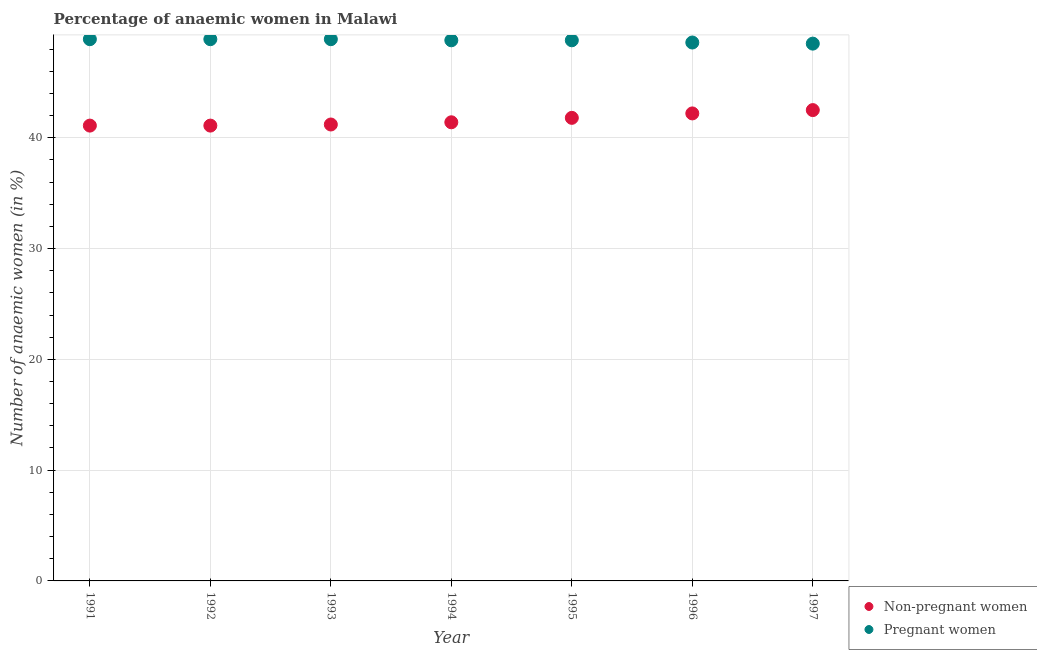Is the number of dotlines equal to the number of legend labels?
Keep it short and to the point. Yes. What is the percentage of non-pregnant anaemic women in 1997?
Your answer should be compact. 42.5. Across all years, what is the maximum percentage of pregnant anaemic women?
Provide a succinct answer. 48.9. Across all years, what is the minimum percentage of non-pregnant anaemic women?
Offer a very short reply. 41.1. What is the total percentage of pregnant anaemic women in the graph?
Offer a very short reply. 341.4. What is the difference between the percentage of non-pregnant anaemic women in 1991 and that in 1996?
Your answer should be very brief. -1.1. What is the difference between the percentage of non-pregnant anaemic women in 1997 and the percentage of pregnant anaemic women in 1992?
Provide a short and direct response. -6.4. What is the average percentage of pregnant anaemic women per year?
Make the answer very short. 48.77. In the year 1997, what is the difference between the percentage of non-pregnant anaemic women and percentage of pregnant anaemic women?
Keep it short and to the point. -6. What is the ratio of the percentage of pregnant anaemic women in 1991 to that in 1997?
Ensure brevity in your answer.  1.01. Is the percentage of non-pregnant anaemic women in 1992 less than that in 1994?
Offer a terse response. Yes. What is the difference between the highest and the lowest percentage of pregnant anaemic women?
Offer a terse response. 0.4. In how many years, is the percentage of pregnant anaemic women greater than the average percentage of pregnant anaemic women taken over all years?
Give a very brief answer. 5. Is the sum of the percentage of non-pregnant anaemic women in 1993 and 1995 greater than the maximum percentage of pregnant anaemic women across all years?
Your response must be concise. Yes. Is the percentage of non-pregnant anaemic women strictly greater than the percentage of pregnant anaemic women over the years?
Provide a succinct answer. No. How many years are there in the graph?
Provide a succinct answer. 7. What is the difference between two consecutive major ticks on the Y-axis?
Offer a very short reply. 10. How are the legend labels stacked?
Make the answer very short. Vertical. What is the title of the graph?
Ensure brevity in your answer.  Percentage of anaemic women in Malawi. Does "Crop" appear as one of the legend labels in the graph?
Give a very brief answer. No. What is the label or title of the X-axis?
Provide a short and direct response. Year. What is the label or title of the Y-axis?
Your response must be concise. Number of anaemic women (in %). What is the Number of anaemic women (in %) of Non-pregnant women in 1991?
Keep it short and to the point. 41.1. What is the Number of anaemic women (in %) of Pregnant women in 1991?
Your response must be concise. 48.9. What is the Number of anaemic women (in %) in Non-pregnant women in 1992?
Your response must be concise. 41.1. What is the Number of anaemic women (in %) of Pregnant women in 1992?
Keep it short and to the point. 48.9. What is the Number of anaemic women (in %) in Non-pregnant women in 1993?
Your answer should be very brief. 41.2. What is the Number of anaemic women (in %) of Pregnant women in 1993?
Your answer should be very brief. 48.9. What is the Number of anaemic women (in %) of Non-pregnant women in 1994?
Provide a succinct answer. 41.4. What is the Number of anaemic women (in %) of Pregnant women in 1994?
Provide a succinct answer. 48.8. What is the Number of anaemic women (in %) in Non-pregnant women in 1995?
Give a very brief answer. 41.8. What is the Number of anaemic women (in %) of Pregnant women in 1995?
Keep it short and to the point. 48.8. What is the Number of anaemic women (in %) of Non-pregnant women in 1996?
Provide a succinct answer. 42.2. What is the Number of anaemic women (in %) of Pregnant women in 1996?
Provide a short and direct response. 48.6. What is the Number of anaemic women (in %) of Non-pregnant women in 1997?
Provide a succinct answer. 42.5. What is the Number of anaemic women (in %) of Pregnant women in 1997?
Your response must be concise. 48.5. Across all years, what is the maximum Number of anaemic women (in %) in Non-pregnant women?
Your response must be concise. 42.5. Across all years, what is the maximum Number of anaemic women (in %) of Pregnant women?
Provide a succinct answer. 48.9. Across all years, what is the minimum Number of anaemic women (in %) of Non-pregnant women?
Make the answer very short. 41.1. Across all years, what is the minimum Number of anaemic women (in %) in Pregnant women?
Offer a very short reply. 48.5. What is the total Number of anaemic women (in %) of Non-pregnant women in the graph?
Your response must be concise. 291.3. What is the total Number of anaemic women (in %) of Pregnant women in the graph?
Your response must be concise. 341.4. What is the difference between the Number of anaemic women (in %) in Non-pregnant women in 1991 and that in 1992?
Your answer should be very brief. 0. What is the difference between the Number of anaemic women (in %) of Pregnant women in 1991 and that in 1992?
Offer a very short reply. 0. What is the difference between the Number of anaemic women (in %) of Pregnant women in 1991 and that in 1993?
Provide a short and direct response. 0. What is the difference between the Number of anaemic women (in %) in Non-pregnant women in 1991 and that in 1995?
Ensure brevity in your answer.  -0.7. What is the difference between the Number of anaemic women (in %) of Non-pregnant women in 1991 and that in 1996?
Your response must be concise. -1.1. What is the difference between the Number of anaemic women (in %) in Pregnant women in 1991 and that in 1996?
Ensure brevity in your answer.  0.3. What is the difference between the Number of anaemic women (in %) of Non-pregnant women in 1992 and that in 1995?
Your response must be concise. -0.7. What is the difference between the Number of anaemic women (in %) in Pregnant women in 1992 and that in 1995?
Make the answer very short. 0.1. What is the difference between the Number of anaemic women (in %) of Non-pregnant women in 1992 and that in 1996?
Give a very brief answer. -1.1. What is the difference between the Number of anaemic women (in %) in Non-pregnant women in 1992 and that in 1997?
Offer a very short reply. -1.4. What is the difference between the Number of anaemic women (in %) in Non-pregnant women in 1993 and that in 1994?
Offer a terse response. -0.2. What is the difference between the Number of anaemic women (in %) in Pregnant women in 1993 and that in 1994?
Ensure brevity in your answer.  0.1. What is the difference between the Number of anaemic women (in %) of Non-pregnant women in 1993 and that in 1996?
Your response must be concise. -1. What is the difference between the Number of anaemic women (in %) in Non-pregnant women in 1993 and that in 1997?
Your response must be concise. -1.3. What is the difference between the Number of anaemic women (in %) of Non-pregnant women in 1994 and that in 1995?
Your answer should be very brief. -0.4. What is the difference between the Number of anaemic women (in %) of Pregnant women in 1994 and that in 1996?
Offer a terse response. 0.2. What is the difference between the Number of anaemic women (in %) in Non-pregnant women in 1995 and that in 1996?
Offer a terse response. -0.4. What is the difference between the Number of anaemic women (in %) of Pregnant women in 1995 and that in 1996?
Give a very brief answer. 0.2. What is the difference between the Number of anaemic women (in %) in Pregnant women in 1996 and that in 1997?
Offer a terse response. 0.1. What is the difference between the Number of anaemic women (in %) in Non-pregnant women in 1991 and the Number of anaemic women (in %) in Pregnant women in 1992?
Make the answer very short. -7.8. What is the difference between the Number of anaemic women (in %) in Non-pregnant women in 1991 and the Number of anaemic women (in %) in Pregnant women in 1993?
Provide a succinct answer. -7.8. What is the difference between the Number of anaemic women (in %) of Non-pregnant women in 1991 and the Number of anaemic women (in %) of Pregnant women in 1996?
Give a very brief answer. -7.5. What is the difference between the Number of anaemic women (in %) of Non-pregnant women in 1992 and the Number of anaemic women (in %) of Pregnant women in 1993?
Give a very brief answer. -7.8. What is the difference between the Number of anaemic women (in %) of Non-pregnant women in 1992 and the Number of anaemic women (in %) of Pregnant women in 1994?
Ensure brevity in your answer.  -7.7. What is the difference between the Number of anaemic women (in %) in Non-pregnant women in 1993 and the Number of anaemic women (in %) in Pregnant women in 1997?
Your answer should be very brief. -7.3. What is the difference between the Number of anaemic women (in %) in Non-pregnant women in 1994 and the Number of anaemic women (in %) in Pregnant women in 1995?
Ensure brevity in your answer.  -7.4. What is the difference between the Number of anaemic women (in %) in Non-pregnant women in 1994 and the Number of anaemic women (in %) in Pregnant women in 1996?
Provide a short and direct response. -7.2. What is the difference between the Number of anaemic women (in %) in Non-pregnant women in 1994 and the Number of anaemic women (in %) in Pregnant women in 1997?
Give a very brief answer. -7.1. What is the difference between the Number of anaemic women (in %) in Non-pregnant women in 1995 and the Number of anaemic women (in %) in Pregnant women in 1997?
Your answer should be compact. -6.7. What is the difference between the Number of anaemic women (in %) of Non-pregnant women in 1996 and the Number of anaemic women (in %) of Pregnant women in 1997?
Provide a short and direct response. -6.3. What is the average Number of anaemic women (in %) in Non-pregnant women per year?
Your answer should be very brief. 41.61. What is the average Number of anaemic women (in %) in Pregnant women per year?
Your response must be concise. 48.77. In the year 1994, what is the difference between the Number of anaemic women (in %) in Non-pregnant women and Number of anaemic women (in %) in Pregnant women?
Your answer should be very brief. -7.4. What is the ratio of the Number of anaemic women (in %) of Non-pregnant women in 1991 to that in 1992?
Make the answer very short. 1. What is the ratio of the Number of anaemic women (in %) in Pregnant women in 1991 to that in 1992?
Your answer should be compact. 1. What is the ratio of the Number of anaemic women (in %) in Non-pregnant women in 1991 to that in 1993?
Make the answer very short. 1. What is the ratio of the Number of anaemic women (in %) in Pregnant women in 1991 to that in 1993?
Make the answer very short. 1. What is the ratio of the Number of anaemic women (in %) of Non-pregnant women in 1991 to that in 1995?
Your response must be concise. 0.98. What is the ratio of the Number of anaemic women (in %) in Non-pregnant women in 1991 to that in 1996?
Ensure brevity in your answer.  0.97. What is the ratio of the Number of anaemic women (in %) of Pregnant women in 1991 to that in 1996?
Offer a very short reply. 1.01. What is the ratio of the Number of anaemic women (in %) of Non-pregnant women in 1991 to that in 1997?
Offer a terse response. 0.97. What is the ratio of the Number of anaemic women (in %) of Pregnant women in 1991 to that in 1997?
Your response must be concise. 1.01. What is the ratio of the Number of anaemic women (in %) in Pregnant women in 1992 to that in 1993?
Keep it short and to the point. 1. What is the ratio of the Number of anaemic women (in %) in Pregnant women in 1992 to that in 1994?
Make the answer very short. 1. What is the ratio of the Number of anaemic women (in %) in Non-pregnant women in 1992 to that in 1995?
Your response must be concise. 0.98. What is the ratio of the Number of anaemic women (in %) in Non-pregnant women in 1992 to that in 1996?
Ensure brevity in your answer.  0.97. What is the ratio of the Number of anaemic women (in %) of Pregnant women in 1992 to that in 1996?
Keep it short and to the point. 1.01. What is the ratio of the Number of anaemic women (in %) in Non-pregnant women in 1992 to that in 1997?
Your answer should be very brief. 0.97. What is the ratio of the Number of anaemic women (in %) in Pregnant women in 1992 to that in 1997?
Give a very brief answer. 1.01. What is the ratio of the Number of anaemic women (in %) in Pregnant women in 1993 to that in 1994?
Offer a very short reply. 1. What is the ratio of the Number of anaemic women (in %) in Non-pregnant women in 1993 to that in 1995?
Keep it short and to the point. 0.99. What is the ratio of the Number of anaemic women (in %) of Pregnant women in 1993 to that in 1995?
Provide a short and direct response. 1. What is the ratio of the Number of anaemic women (in %) in Non-pregnant women in 1993 to that in 1996?
Your answer should be very brief. 0.98. What is the ratio of the Number of anaemic women (in %) of Pregnant women in 1993 to that in 1996?
Give a very brief answer. 1.01. What is the ratio of the Number of anaemic women (in %) in Non-pregnant women in 1993 to that in 1997?
Offer a terse response. 0.97. What is the ratio of the Number of anaemic women (in %) in Pregnant women in 1993 to that in 1997?
Your answer should be compact. 1.01. What is the ratio of the Number of anaemic women (in %) in Non-pregnant women in 1994 to that in 1995?
Offer a terse response. 0.99. What is the ratio of the Number of anaemic women (in %) of Pregnant women in 1994 to that in 1995?
Give a very brief answer. 1. What is the ratio of the Number of anaemic women (in %) in Non-pregnant women in 1994 to that in 1996?
Make the answer very short. 0.98. What is the ratio of the Number of anaemic women (in %) in Pregnant women in 1994 to that in 1996?
Provide a succinct answer. 1. What is the ratio of the Number of anaemic women (in %) of Non-pregnant women in 1994 to that in 1997?
Provide a short and direct response. 0.97. What is the ratio of the Number of anaemic women (in %) of Non-pregnant women in 1995 to that in 1997?
Make the answer very short. 0.98. What is the ratio of the Number of anaemic women (in %) of Pregnant women in 1995 to that in 1997?
Offer a terse response. 1.01. What is the ratio of the Number of anaemic women (in %) in Non-pregnant women in 1996 to that in 1997?
Keep it short and to the point. 0.99. What is the ratio of the Number of anaemic women (in %) in Pregnant women in 1996 to that in 1997?
Make the answer very short. 1. What is the difference between the highest and the second highest Number of anaemic women (in %) of Non-pregnant women?
Provide a succinct answer. 0.3. What is the difference between the highest and the second highest Number of anaemic women (in %) in Pregnant women?
Your answer should be very brief. 0. What is the difference between the highest and the lowest Number of anaemic women (in %) of Non-pregnant women?
Give a very brief answer. 1.4. 